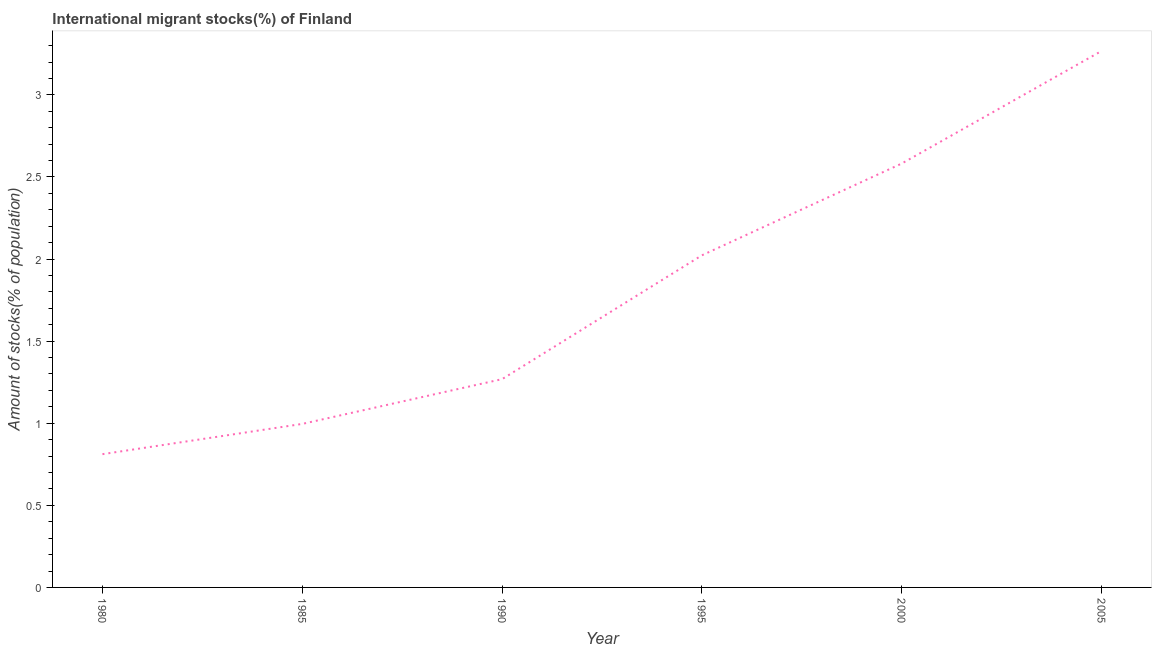What is the number of international migrant stocks in 2005?
Provide a short and direct response. 3.27. Across all years, what is the maximum number of international migrant stocks?
Your response must be concise. 3.27. Across all years, what is the minimum number of international migrant stocks?
Ensure brevity in your answer.  0.81. In which year was the number of international migrant stocks maximum?
Offer a very short reply. 2005. In which year was the number of international migrant stocks minimum?
Your answer should be compact. 1980. What is the sum of the number of international migrant stocks?
Your response must be concise. 10.95. What is the difference between the number of international migrant stocks in 1985 and 1995?
Your answer should be very brief. -1.03. What is the average number of international migrant stocks per year?
Keep it short and to the point. 1.82. What is the median number of international migrant stocks?
Provide a short and direct response. 1.65. What is the ratio of the number of international migrant stocks in 1990 to that in 2005?
Offer a terse response. 0.39. Is the difference between the number of international migrant stocks in 1990 and 2005 greater than the difference between any two years?
Give a very brief answer. No. What is the difference between the highest and the second highest number of international migrant stocks?
Ensure brevity in your answer.  0.69. What is the difference between the highest and the lowest number of international migrant stocks?
Keep it short and to the point. 2.46. In how many years, is the number of international migrant stocks greater than the average number of international migrant stocks taken over all years?
Your response must be concise. 3. Does the number of international migrant stocks monotonically increase over the years?
Keep it short and to the point. Yes. How many lines are there?
Offer a very short reply. 1. What is the difference between two consecutive major ticks on the Y-axis?
Provide a succinct answer. 0.5. Does the graph contain any zero values?
Ensure brevity in your answer.  No. What is the title of the graph?
Offer a very short reply. International migrant stocks(%) of Finland. What is the label or title of the X-axis?
Your response must be concise. Year. What is the label or title of the Y-axis?
Give a very brief answer. Amount of stocks(% of population). What is the Amount of stocks(% of population) of 1980?
Offer a terse response. 0.81. What is the Amount of stocks(% of population) in 1985?
Provide a succinct answer. 1. What is the Amount of stocks(% of population) in 1990?
Make the answer very short. 1.27. What is the Amount of stocks(% of population) in 1995?
Offer a terse response. 2.02. What is the Amount of stocks(% of population) of 2000?
Give a very brief answer. 2.58. What is the Amount of stocks(% of population) in 2005?
Give a very brief answer. 3.27. What is the difference between the Amount of stocks(% of population) in 1980 and 1985?
Offer a terse response. -0.18. What is the difference between the Amount of stocks(% of population) in 1980 and 1990?
Offer a very short reply. -0.46. What is the difference between the Amount of stocks(% of population) in 1980 and 1995?
Provide a short and direct response. -1.21. What is the difference between the Amount of stocks(% of population) in 1980 and 2000?
Keep it short and to the point. -1.77. What is the difference between the Amount of stocks(% of population) in 1980 and 2005?
Ensure brevity in your answer.  -2.46. What is the difference between the Amount of stocks(% of population) in 1985 and 1990?
Offer a very short reply. -0.27. What is the difference between the Amount of stocks(% of population) in 1985 and 1995?
Ensure brevity in your answer.  -1.03. What is the difference between the Amount of stocks(% of population) in 1985 and 2000?
Offer a terse response. -1.59. What is the difference between the Amount of stocks(% of population) in 1985 and 2005?
Your answer should be very brief. -2.27. What is the difference between the Amount of stocks(% of population) in 1990 and 1995?
Your answer should be very brief. -0.75. What is the difference between the Amount of stocks(% of population) in 1990 and 2000?
Provide a succinct answer. -1.31. What is the difference between the Amount of stocks(% of population) in 1990 and 2005?
Make the answer very short. -2. What is the difference between the Amount of stocks(% of population) in 1995 and 2000?
Your response must be concise. -0.56. What is the difference between the Amount of stocks(% of population) in 1995 and 2005?
Your answer should be very brief. -1.24. What is the difference between the Amount of stocks(% of population) in 2000 and 2005?
Your answer should be compact. -0.69. What is the ratio of the Amount of stocks(% of population) in 1980 to that in 1985?
Keep it short and to the point. 0.81. What is the ratio of the Amount of stocks(% of population) in 1980 to that in 1990?
Offer a very short reply. 0.64. What is the ratio of the Amount of stocks(% of population) in 1980 to that in 1995?
Your answer should be compact. 0.4. What is the ratio of the Amount of stocks(% of population) in 1980 to that in 2000?
Keep it short and to the point. 0.31. What is the ratio of the Amount of stocks(% of population) in 1980 to that in 2005?
Ensure brevity in your answer.  0.25. What is the ratio of the Amount of stocks(% of population) in 1985 to that in 1990?
Provide a succinct answer. 0.79. What is the ratio of the Amount of stocks(% of population) in 1985 to that in 1995?
Make the answer very short. 0.49. What is the ratio of the Amount of stocks(% of population) in 1985 to that in 2000?
Offer a very short reply. 0.39. What is the ratio of the Amount of stocks(% of population) in 1985 to that in 2005?
Make the answer very short. 0.3. What is the ratio of the Amount of stocks(% of population) in 1990 to that in 1995?
Give a very brief answer. 0.63. What is the ratio of the Amount of stocks(% of population) in 1990 to that in 2000?
Your answer should be compact. 0.49. What is the ratio of the Amount of stocks(% of population) in 1990 to that in 2005?
Offer a terse response. 0.39. What is the ratio of the Amount of stocks(% of population) in 1995 to that in 2000?
Provide a succinct answer. 0.78. What is the ratio of the Amount of stocks(% of population) in 1995 to that in 2005?
Your answer should be compact. 0.62. What is the ratio of the Amount of stocks(% of population) in 2000 to that in 2005?
Give a very brief answer. 0.79. 